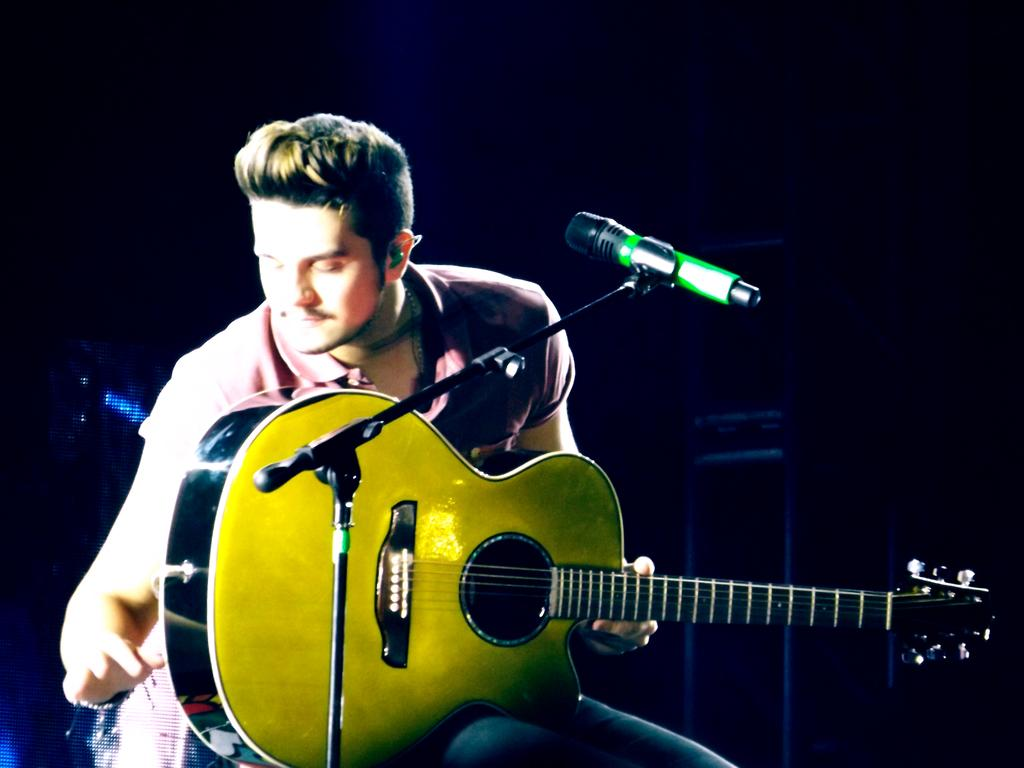What is the man in the image doing? The man is sitting on a chair in the image. What object is the man holding? The man is holding a guitar. What is in front of the man? There is a microphone in front of the man. What can be seen in the background of the image? Musical instruments are visible in the background of the image. What type of tramp can be seen jumping in the image? There is no tramp present in the image. What nation is the man from in the image? The image does not provide information about the man's nationality. 